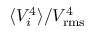<formula> <loc_0><loc_0><loc_500><loc_500>\langle V _ { i } ^ { 4 } \rangle / V _ { r m s } ^ { 4 }</formula> 